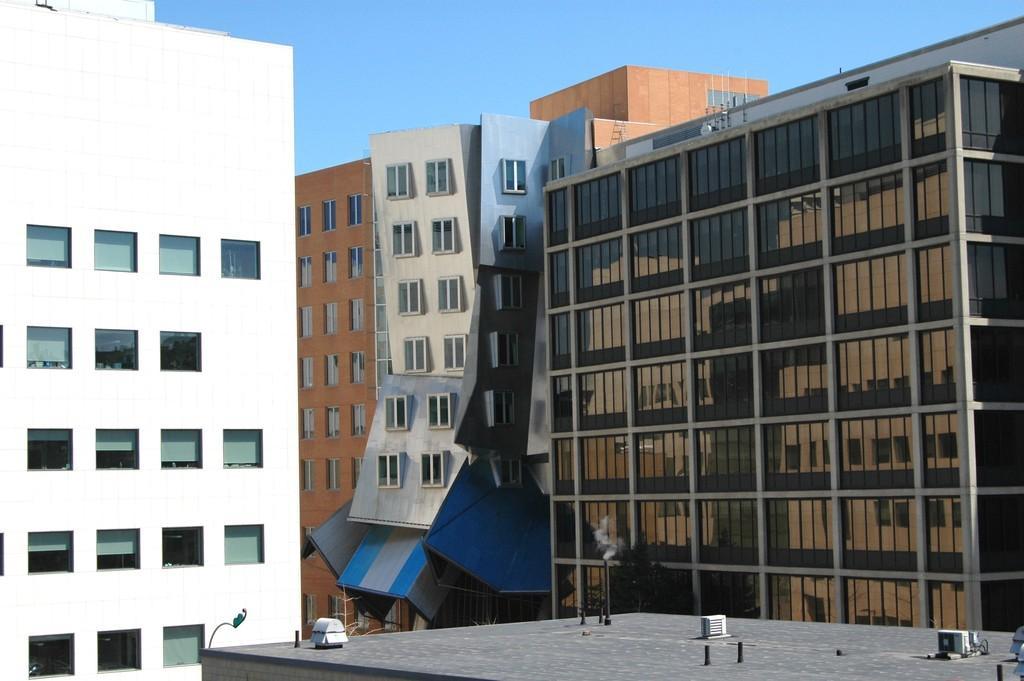Please provide a concise description of this image. In this image I can see many buildings which are in white, brown and grey color. In the background I can see the blue sky. 